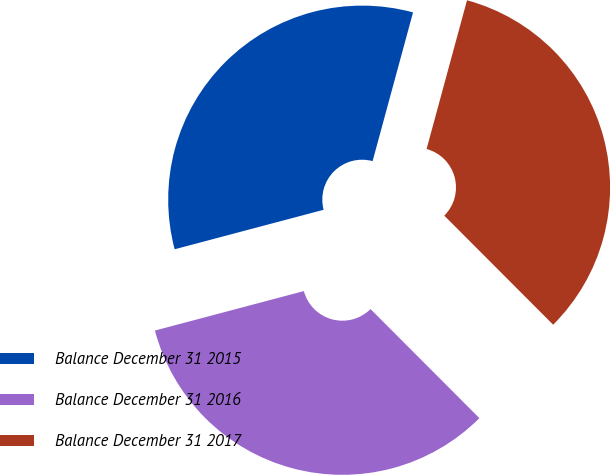Convert chart. <chart><loc_0><loc_0><loc_500><loc_500><pie_chart><fcel>Balance December 31 2015<fcel>Balance December 31 2016<fcel>Balance December 31 2017<nl><fcel>33.35%<fcel>33.36%<fcel>33.29%<nl></chart> 